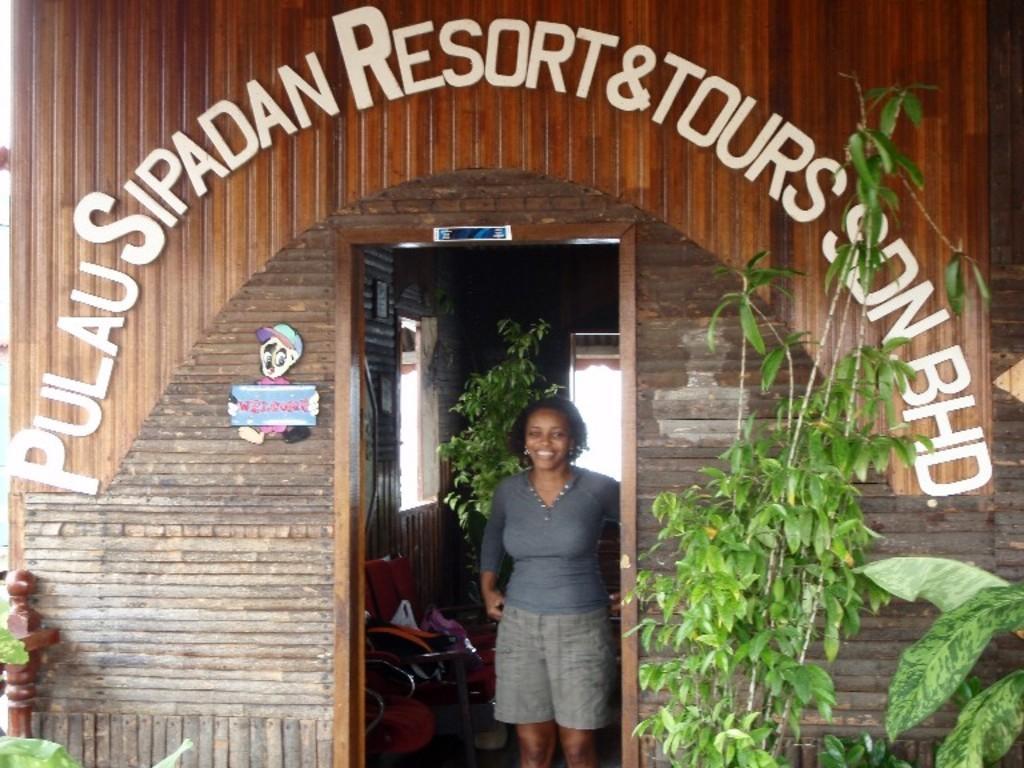Could you give a brief overview of what you see in this image? In this picture we can see a room, there is a woman standing and smiling in the middle, we can also see chairs in the middle, on the right side we can see plants, in the background there is a window and another planet, we can see some text in the front. 